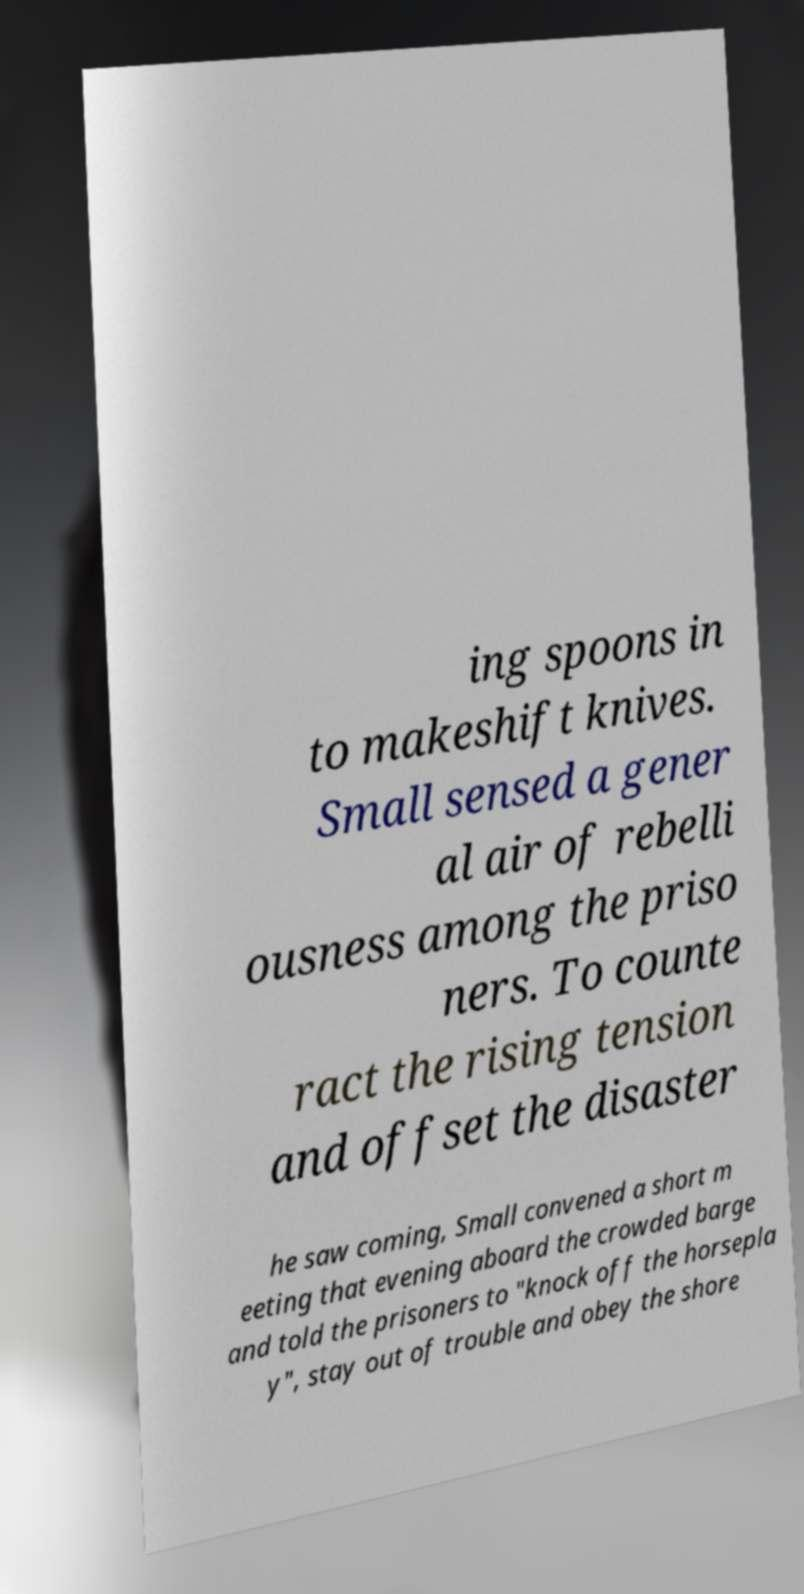There's text embedded in this image that I need extracted. Can you transcribe it verbatim? ing spoons in to makeshift knives. Small sensed a gener al air of rebelli ousness among the priso ners. To counte ract the rising tension and offset the disaster he saw coming, Small convened a short m eeting that evening aboard the crowded barge and told the prisoners to "knock off the horsepla y", stay out of trouble and obey the shore 